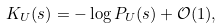Convert formula to latex. <formula><loc_0><loc_0><loc_500><loc_500>K _ { U } ( s ) = - \log P _ { U } ( s ) + \mathcal { O } ( 1 ) ,</formula> 